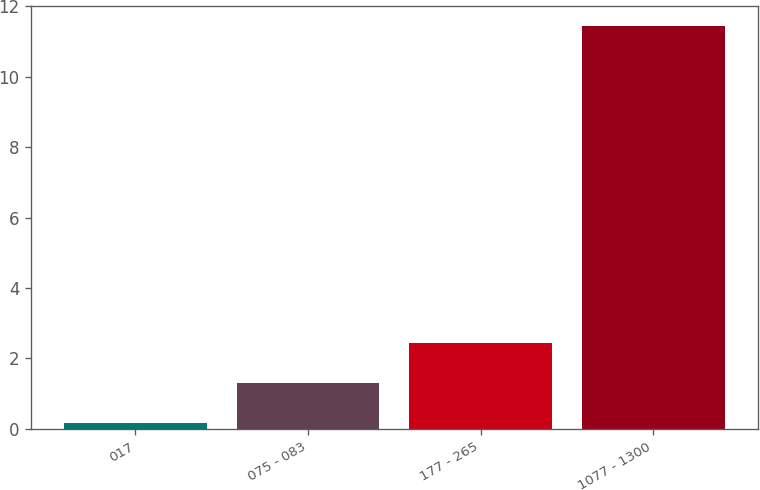<chart> <loc_0><loc_0><loc_500><loc_500><bar_chart><fcel>017<fcel>075 - 083<fcel>177 - 265<fcel>1077 - 1300<nl><fcel>0.17<fcel>1.3<fcel>2.43<fcel>11.43<nl></chart> 